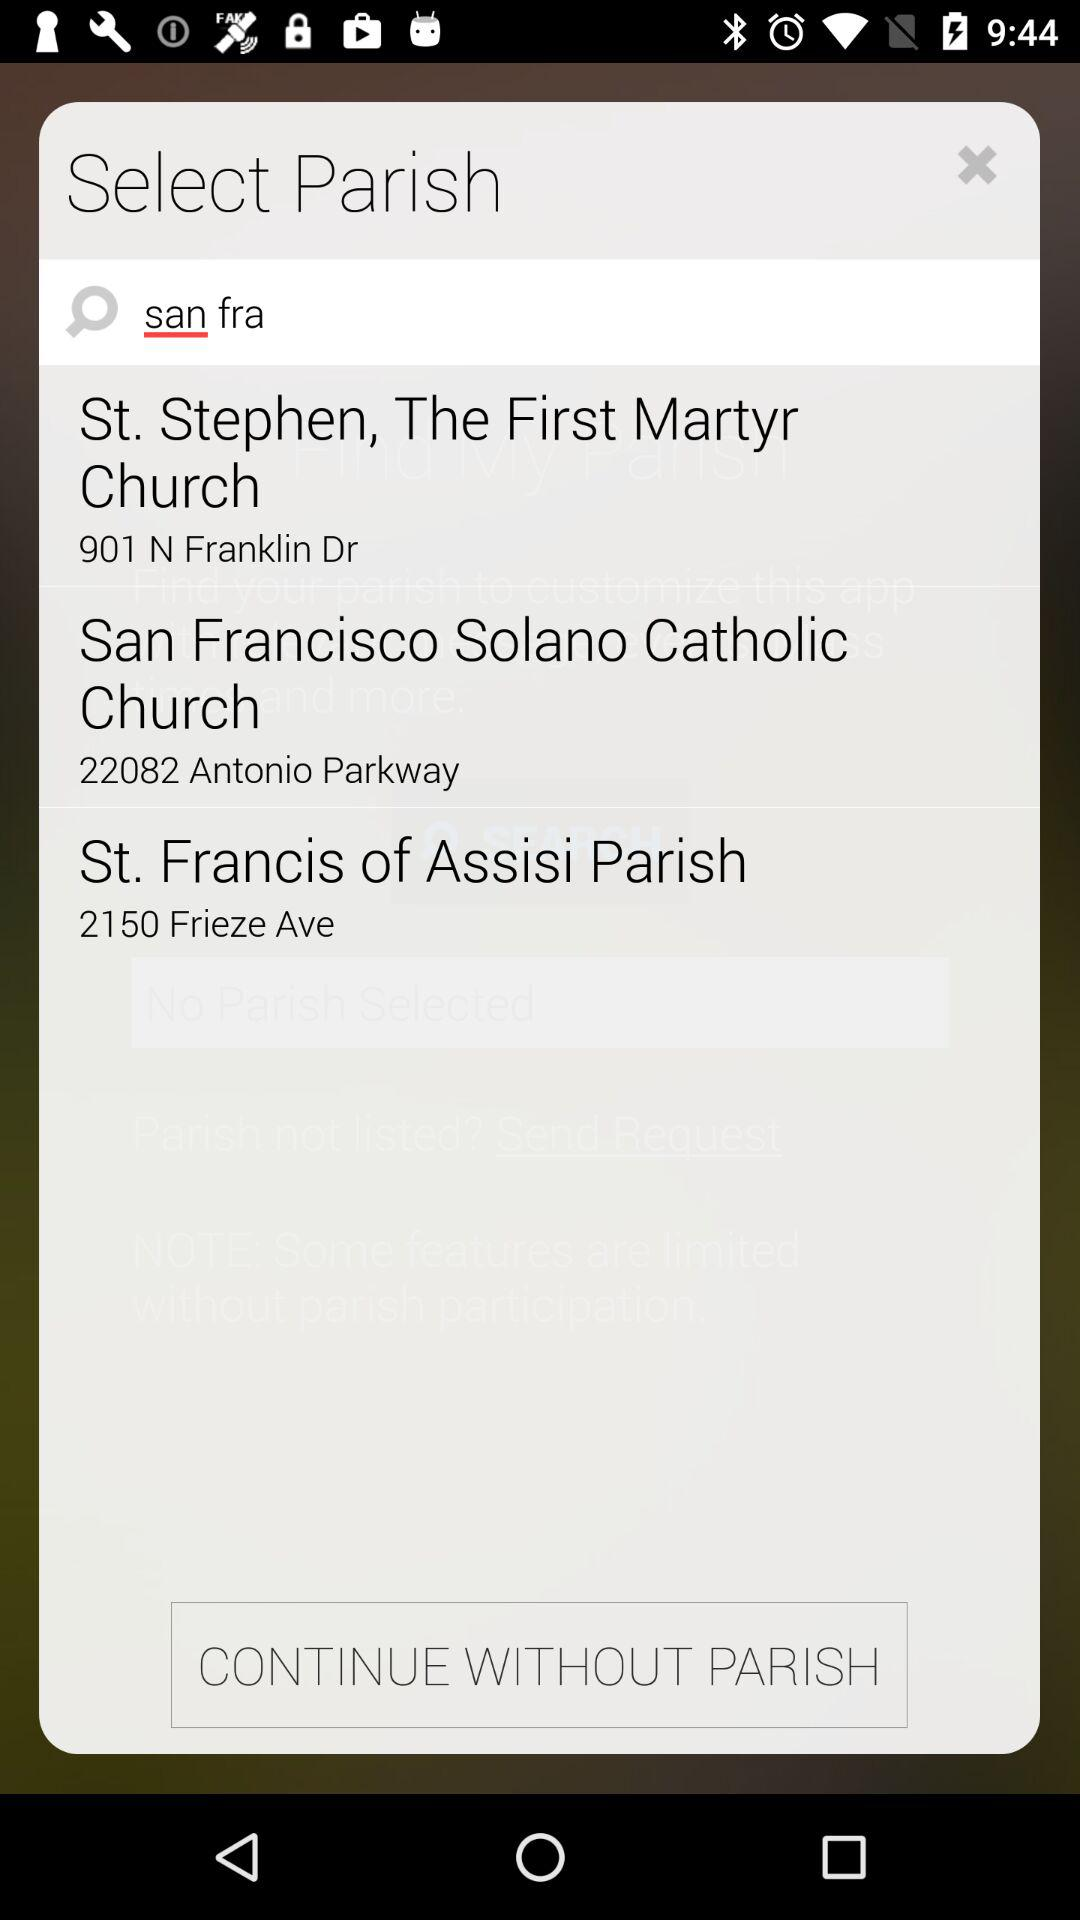How many parishes are displayed?
Answer the question using a single word or phrase. 3 